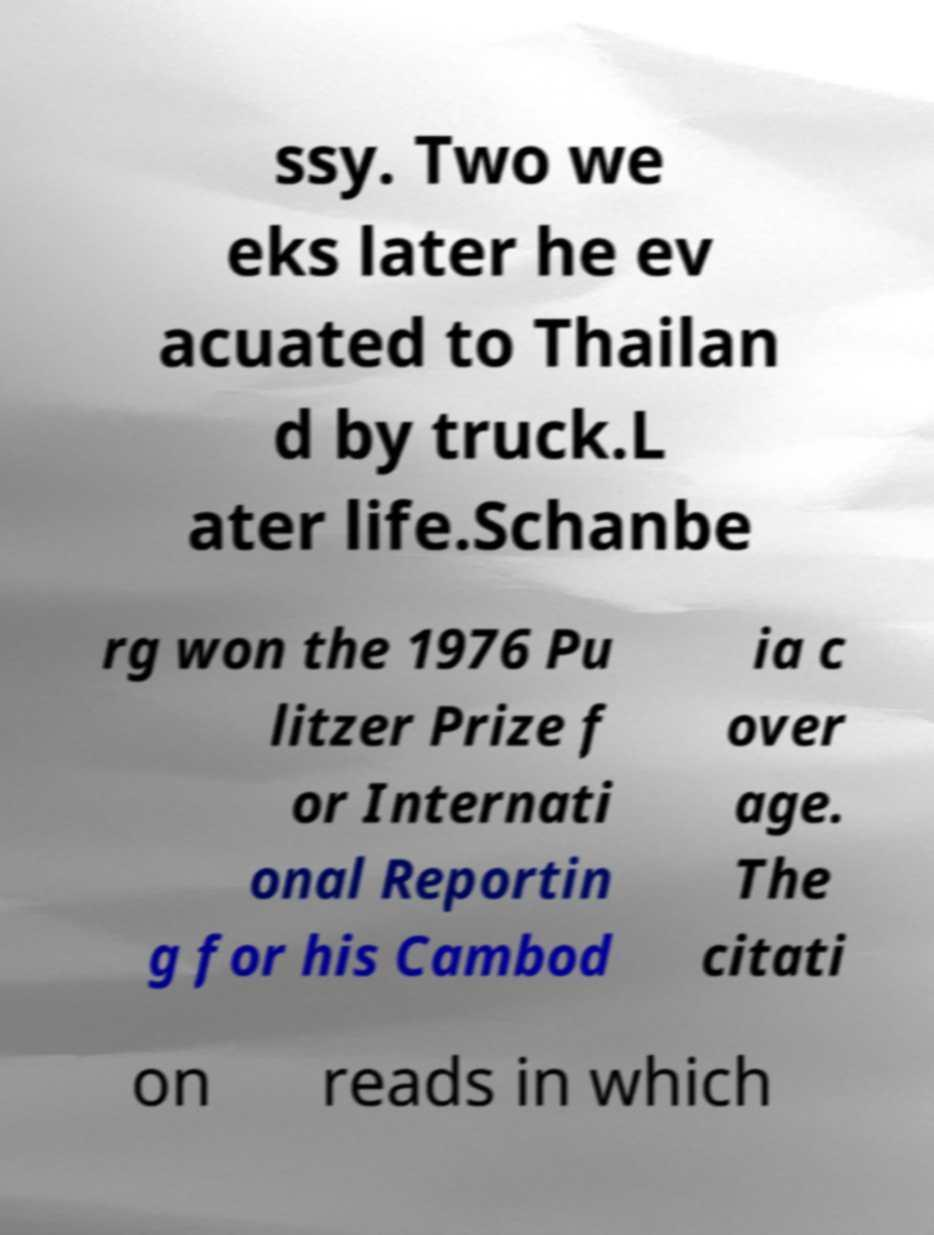I need the written content from this picture converted into text. Can you do that? ssy. Two we eks later he ev acuated to Thailan d by truck.L ater life.Schanbe rg won the 1976 Pu litzer Prize f or Internati onal Reportin g for his Cambod ia c over age. The citati on reads in which 